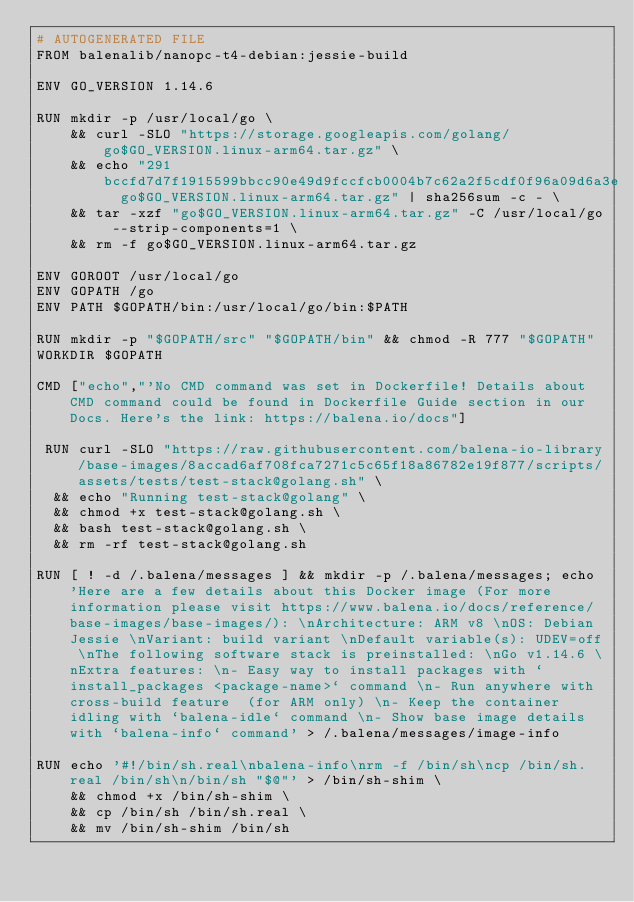Convert code to text. <code><loc_0><loc_0><loc_500><loc_500><_Dockerfile_># AUTOGENERATED FILE
FROM balenalib/nanopc-t4-debian:jessie-build

ENV GO_VERSION 1.14.6

RUN mkdir -p /usr/local/go \
	&& curl -SLO "https://storage.googleapis.com/golang/go$GO_VERSION.linux-arm64.tar.gz" \
	&& echo "291bccfd7d7f1915599bbcc90e49d9fccfcb0004b7c62a2f5cdf0f96a09d6a3e  go$GO_VERSION.linux-arm64.tar.gz" | sha256sum -c - \
	&& tar -xzf "go$GO_VERSION.linux-arm64.tar.gz" -C /usr/local/go --strip-components=1 \
	&& rm -f go$GO_VERSION.linux-arm64.tar.gz

ENV GOROOT /usr/local/go
ENV GOPATH /go
ENV PATH $GOPATH/bin:/usr/local/go/bin:$PATH

RUN mkdir -p "$GOPATH/src" "$GOPATH/bin" && chmod -R 777 "$GOPATH"
WORKDIR $GOPATH

CMD ["echo","'No CMD command was set in Dockerfile! Details about CMD command could be found in Dockerfile Guide section in our Docs. Here's the link: https://balena.io/docs"]

 RUN curl -SLO "https://raw.githubusercontent.com/balena-io-library/base-images/8accad6af708fca7271c5c65f18a86782e19f877/scripts/assets/tests/test-stack@golang.sh" \
  && echo "Running test-stack@golang" \
  && chmod +x test-stack@golang.sh \
  && bash test-stack@golang.sh \
  && rm -rf test-stack@golang.sh 

RUN [ ! -d /.balena/messages ] && mkdir -p /.balena/messages; echo 'Here are a few details about this Docker image (For more information please visit https://www.balena.io/docs/reference/base-images/base-images/): \nArchitecture: ARM v8 \nOS: Debian Jessie \nVariant: build variant \nDefault variable(s): UDEV=off \nThe following software stack is preinstalled: \nGo v1.14.6 \nExtra features: \n- Easy way to install packages with `install_packages <package-name>` command \n- Run anywhere with cross-build feature  (for ARM only) \n- Keep the container idling with `balena-idle` command \n- Show base image details with `balena-info` command' > /.balena/messages/image-info

RUN echo '#!/bin/sh.real\nbalena-info\nrm -f /bin/sh\ncp /bin/sh.real /bin/sh\n/bin/sh "$@"' > /bin/sh-shim \
	&& chmod +x /bin/sh-shim \
	&& cp /bin/sh /bin/sh.real \
	&& mv /bin/sh-shim /bin/sh</code> 